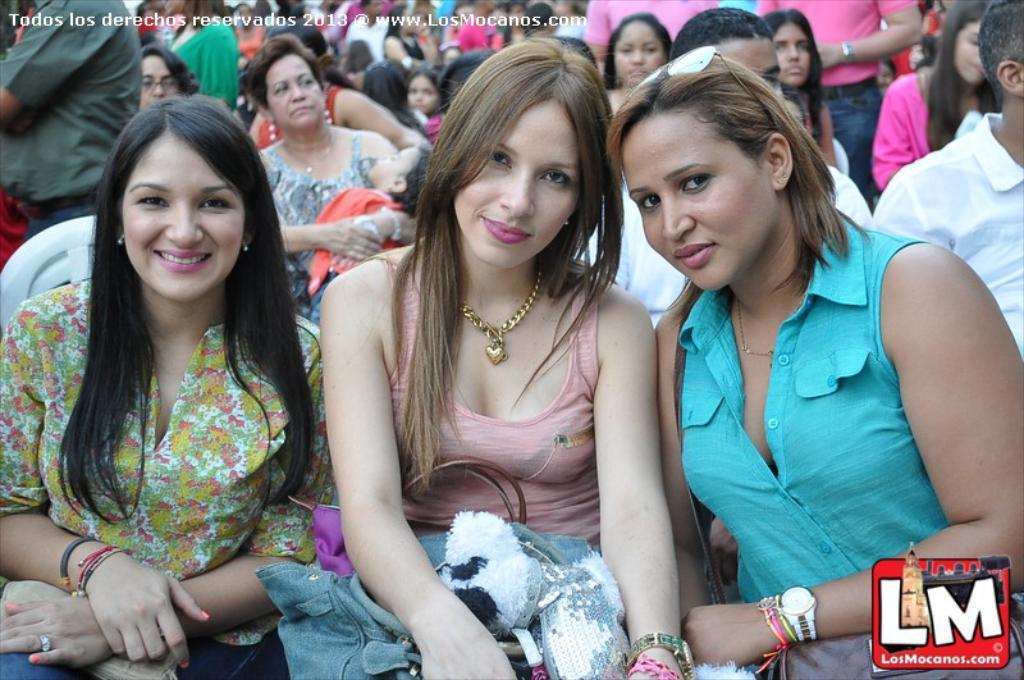Please provide a concise description of this image. In this picture we can see three women smiling, bags, watches, goggles, logo and in the background we can see a group of people. 